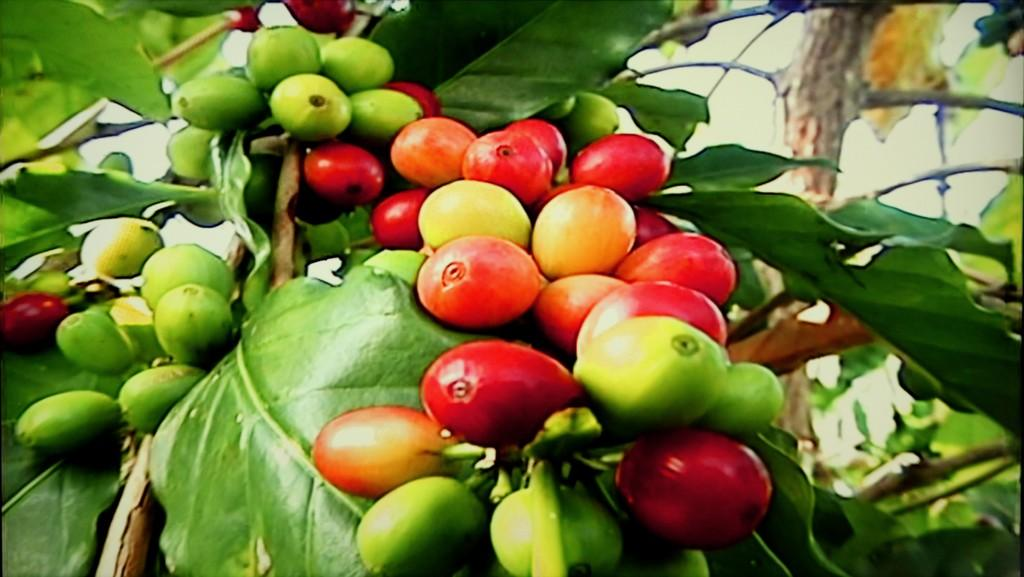What type of fruits can be seen on the tree in the image? There are ripe fruits and unripe fruits on the branches of a tree. Can you describe the difference between the ripe and unripe fruits? The ripe fruits are fully grown and have a different color compared to the unripe fruits, which are still growing. What type of park can be seen in the background of the image? There is no park visible in the image; it only features a tree with fruits. How does the brain of the unripe fruit differ from the ripe fruit? The image does not show the internal structure of the fruits, so it is not possible to compare their brains. 